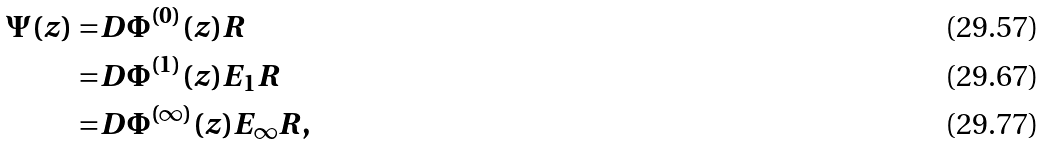Convert formula to latex. <formula><loc_0><loc_0><loc_500><loc_500>\Psi ( z ) = & D \Phi ^ { ( 0 ) } ( z ) R \\ = & D \Phi ^ { ( 1 ) } ( z ) E _ { 1 } R \\ = & D \Phi ^ { ( \infty ) } ( z ) E _ { \infty } R ,</formula> 